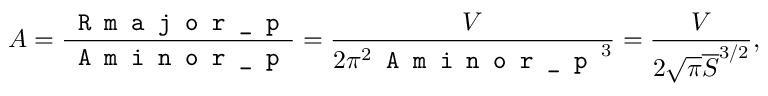Convert formula to latex. <formula><loc_0><loc_0><loc_500><loc_500>A = \frac { R m a j o r \_ p } { A \min o r \_ p } = \frac { V } { 2 \pi ^ { 2 } A \min o r \_ p ^ { 3 } } = \frac { V } { 2 \sqrt { \pi } \overline { S } ^ { 3 / 2 } } ,</formula> 